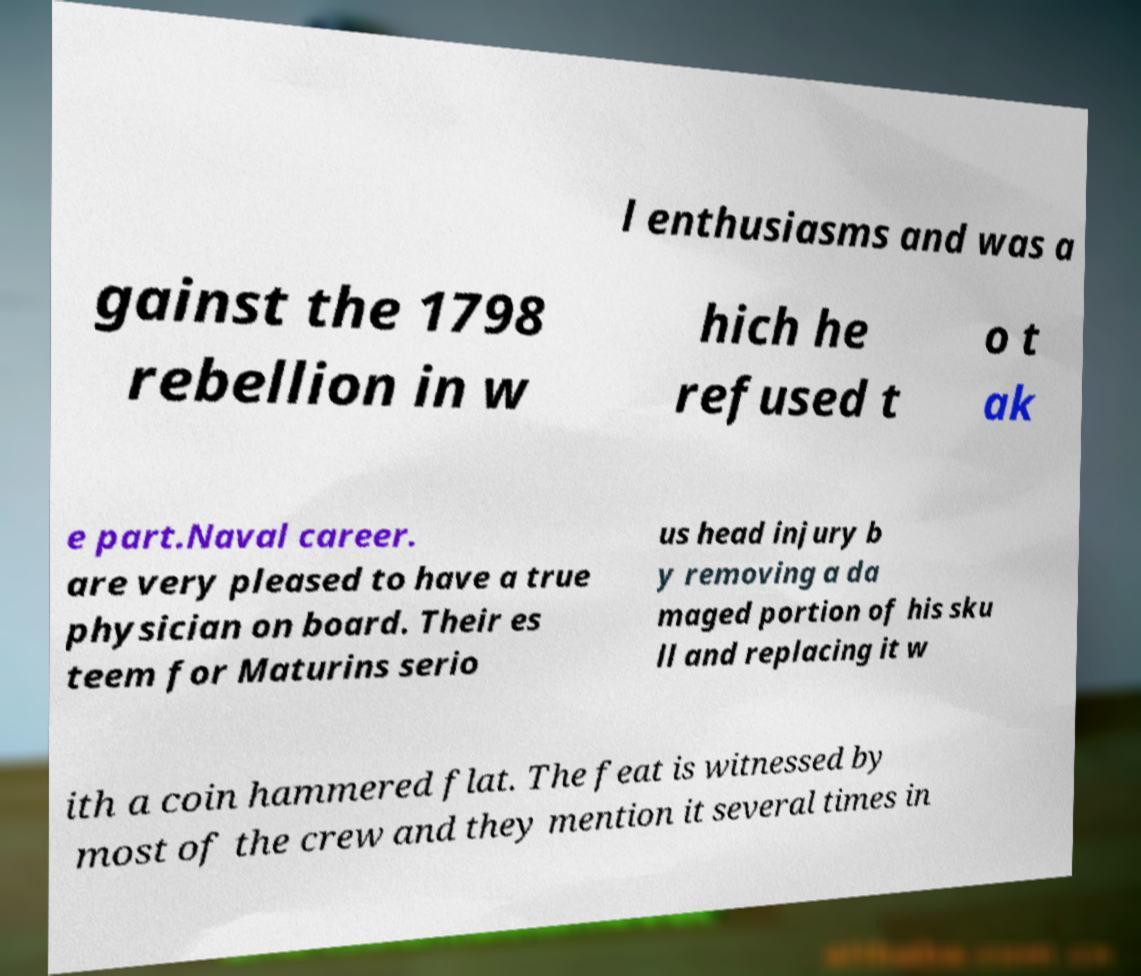Could you assist in decoding the text presented in this image and type it out clearly? l enthusiasms and was a gainst the 1798 rebellion in w hich he refused t o t ak e part.Naval career. are very pleased to have a true physician on board. Their es teem for Maturins serio us head injury b y removing a da maged portion of his sku ll and replacing it w ith a coin hammered flat. The feat is witnessed by most of the crew and they mention it several times in 